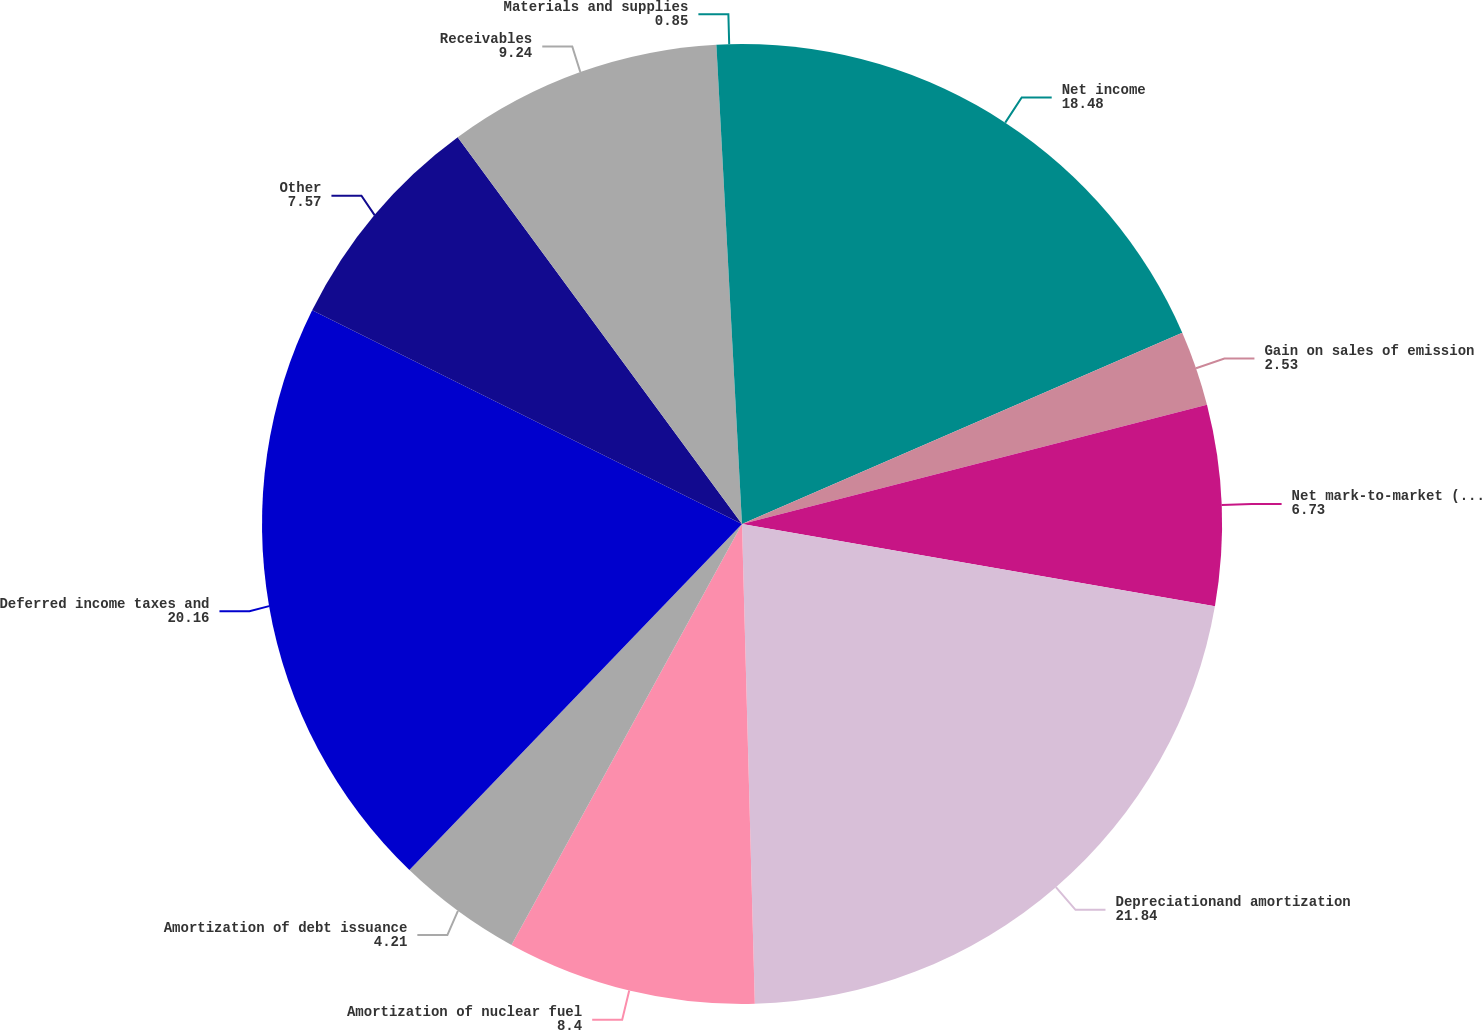<chart> <loc_0><loc_0><loc_500><loc_500><pie_chart><fcel>Net income<fcel>Gain on sales of emission<fcel>Net mark-to-market (gain) loss<fcel>Depreciationand amortization<fcel>Amortization of nuclear fuel<fcel>Amortization of debt issuance<fcel>Deferred income taxes and<fcel>Other<fcel>Receivables<fcel>Materials and supplies<nl><fcel>18.48%<fcel>2.53%<fcel>6.73%<fcel>21.84%<fcel>8.4%<fcel>4.21%<fcel>20.16%<fcel>7.57%<fcel>9.24%<fcel>0.85%<nl></chart> 